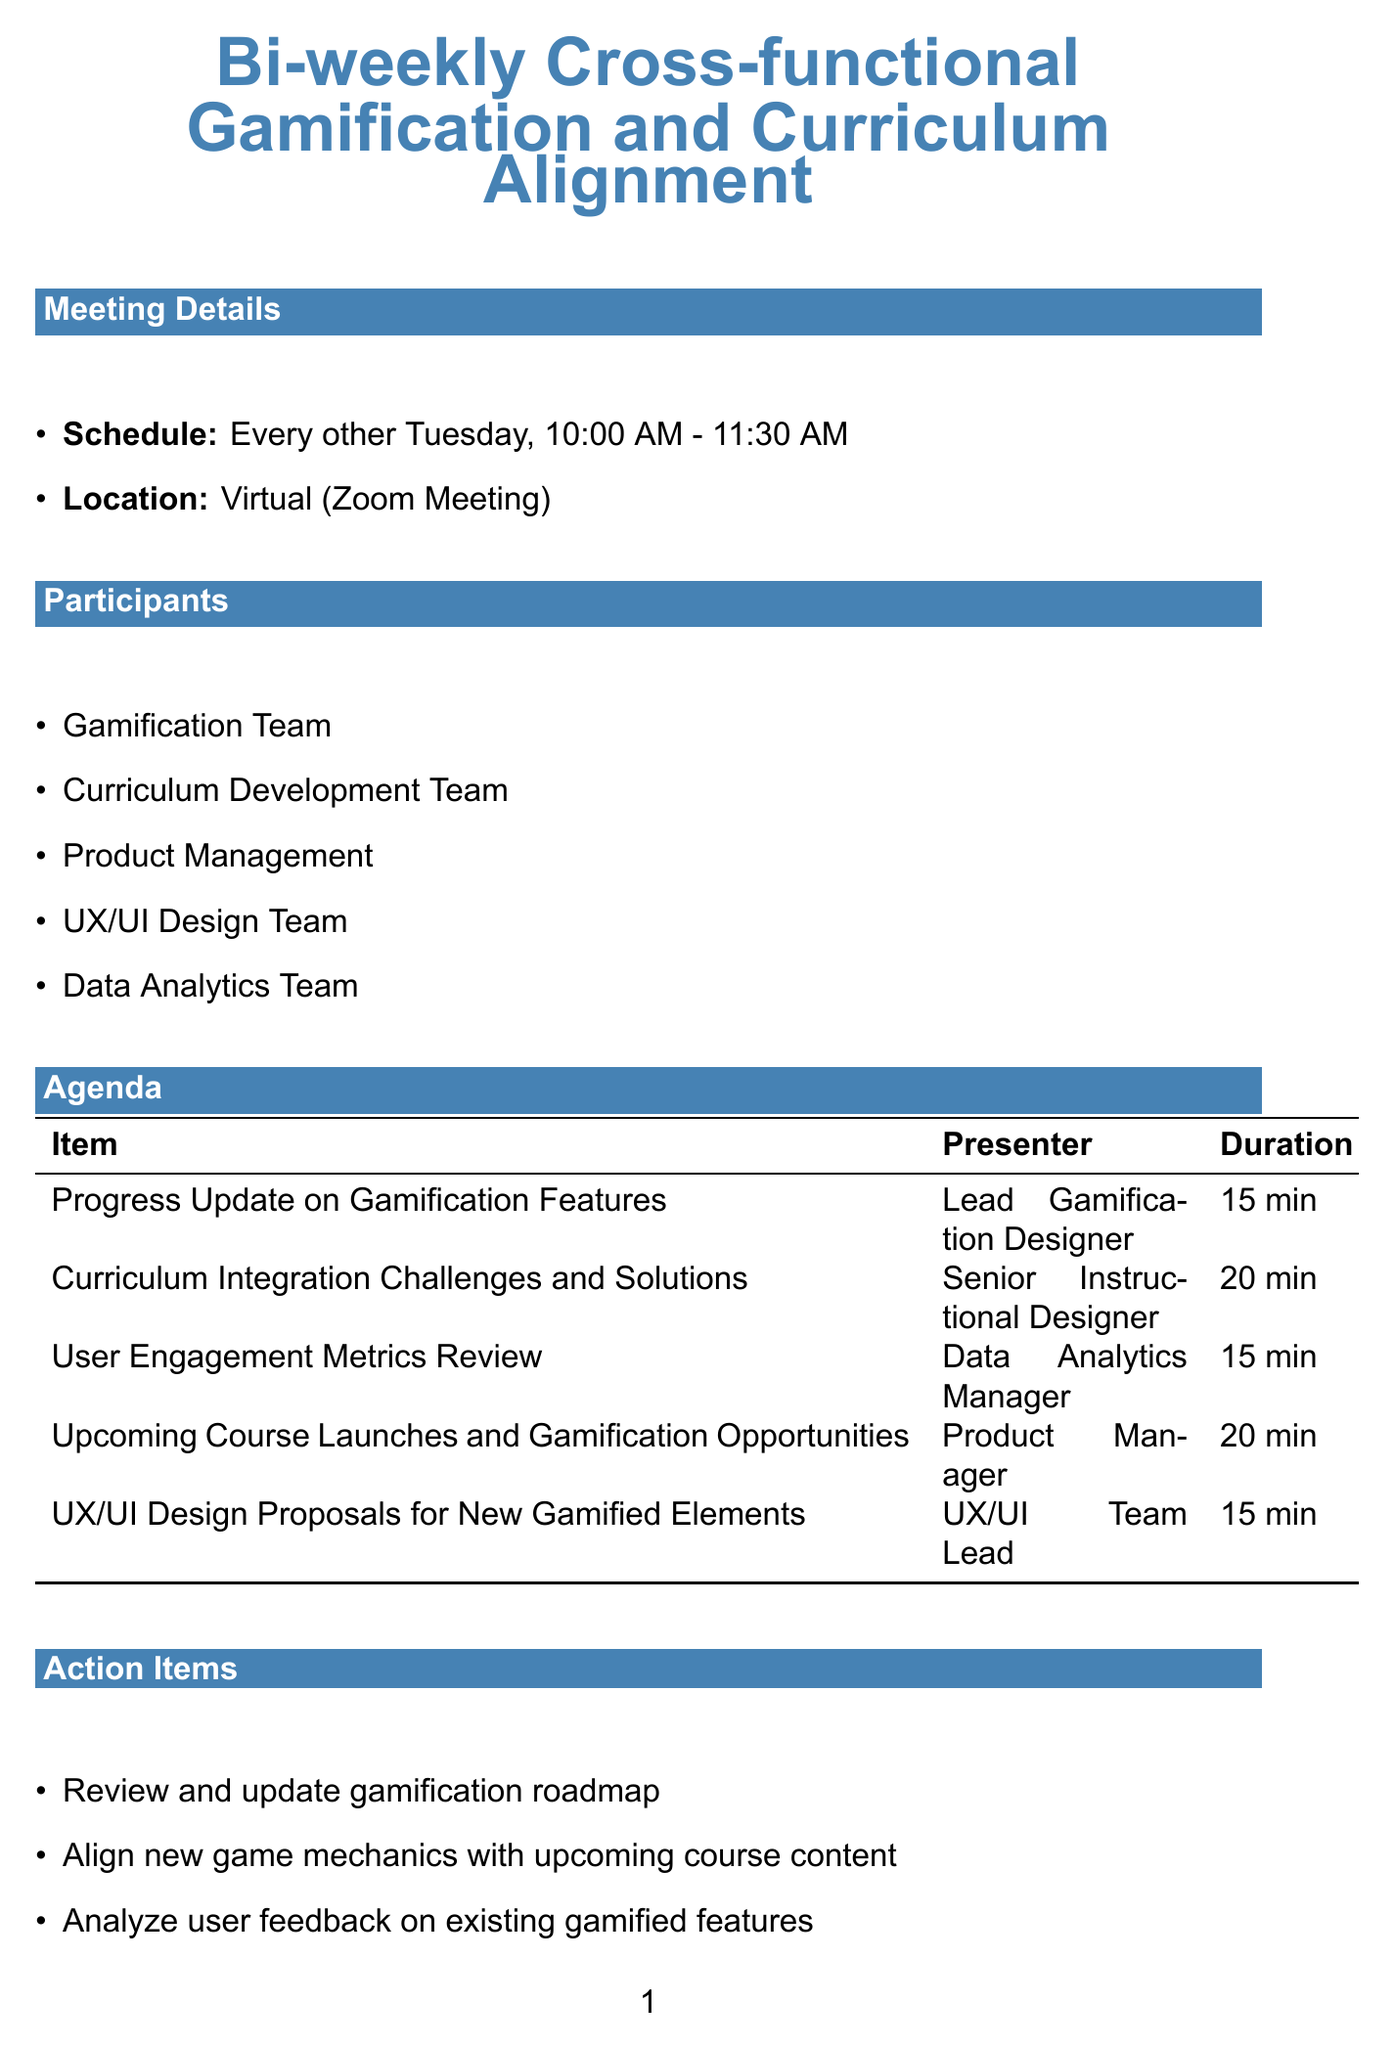What is the title of the meeting? The title of the meeting is mentioned at the beginning of the document.
Answer: Bi-weekly Cross-functional Gamification and Curriculum Alignment How often does the meeting occur? The frequency of the meeting is stated in the schedule section.
Answer: Every other Tuesday What is the duration of the User Engagement Metrics Review? The duration of the agenda item is specified in the table of agenda items.
Answer: 15 minutes Who presents the Curriculum Integration Challenges and Solutions? The presenter for this agenda item is indicated in the agenda section.
Answer: Senior Instructional Designer What tool is used for data visualization? The purpose of the tools is listed in the tools and resources section.
Answer: Tableau Name one of the upcoming milestones. The upcoming milestones are listed with their titles and dates.
Answer: Launch of 'Code Quest' Programming Challenge What is the focus of the competitor analysis? The focus of the analysis is clearly stated in the competitor analysis section.
Answer: Identifying unique gamification strategies to maintain competitive edge Which team is responsible for presenting UX/UI Design Proposals for New Gamified Elements? The responsible team is listed in the agenda items section of the document.
Answer: UX/UI Team Lead 